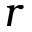Convert formula to latex. <formula><loc_0><loc_0><loc_500><loc_500>r</formula> 